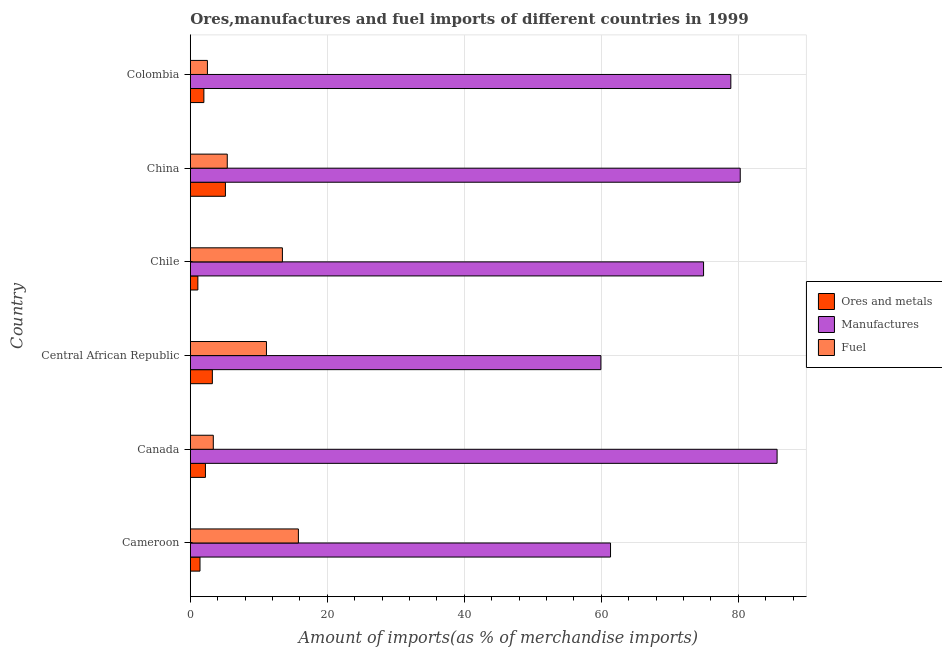How many different coloured bars are there?
Ensure brevity in your answer.  3. Are the number of bars per tick equal to the number of legend labels?
Provide a succinct answer. Yes. What is the label of the 5th group of bars from the top?
Your answer should be very brief. Canada. In how many cases, is the number of bars for a given country not equal to the number of legend labels?
Keep it short and to the point. 0. What is the percentage of manufactures imports in Chile?
Provide a succinct answer. 74.93. Across all countries, what is the maximum percentage of ores and metals imports?
Offer a terse response. 5.13. Across all countries, what is the minimum percentage of ores and metals imports?
Offer a terse response. 1.11. In which country was the percentage of fuel imports maximum?
Provide a succinct answer. Cameroon. What is the total percentage of manufactures imports in the graph?
Keep it short and to the point. 441.09. What is the difference between the percentage of fuel imports in Chile and that in China?
Your response must be concise. 8.05. What is the difference between the percentage of fuel imports in Colombia and the percentage of ores and metals imports in Chile?
Ensure brevity in your answer.  1.4. What is the average percentage of ores and metals imports per country?
Give a very brief answer. 2.51. What is the difference between the percentage of manufactures imports and percentage of fuel imports in Colombia?
Give a very brief answer. 76.41. In how many countries, is the percentage of ores and metals imports greater than 52 %?
Make the answer very short. 0. What is the ratio of the percentage of fuel imports in Canada to that in China?
Offer a terse response. 0.62. What is the difference between the highest and the second highest percentage of ores and metals imports?
Your response must be concise. 1.91. What is the difference between the highest and the lowest percentage of fuel imports?
Your response must be concise. 13.28. What does the 3rd bar from the top in Colombia represents?
Provide a short and direct response. Ores and metals. What does the 2nd bar from the bottom in Colombia represents?
Provide a succinct answer. Manufactures. Are all the bars in the graph horizontal?
Ensure brevity in your answer.  Yes. Does the graph contain any zero values?
Keep it short and to the point. No. Does the graph contain grids?
Offer a very short reply. Yes. How many legend labels are there?
Your answer should be compact. 3. How are the legend labels stacked?
Offer a terse response. Vertical. What is the title of the graph?
Make the answer very short. Ores,manufactures and fuel imports of different countries in 1999. Does "Manufactures" appear as one of the legend labels in the graph?
Your response must be concise. Yes. What is the label or title of the X-axis?
Your response must be concise. Amount of imports(as % of merchandise imports). What is the Amount of imports(as % of merchandise imports) of Ores and metals in Cameroon?
Your answer should be compact. 1.42. What is the Amount of imports(as % of merchandise imports) in Manufactures in Cameroon?
Your response must be concise. 61.35. What is the Amount of imports(as % of merchandise imports) of Fuel in Cameroon?
Your response must be concise. 15.78. What is the Amount of imports(as % of merchandise imports) of Ores and metals in Canada?
Offer a terse response. 2.21. What is the Amount of imports(as % of merchandise imports) of Manufactures in Canada?
Ensure brevity in your answer.  85.67. What is the Amount of imports(as % of merchandise imports) in Fuel in Canada?
Give a very brief answer. 3.36. What is the Amount of imports(as % of merchandise imports) of Ores and metals in Central African Republic?
Offer a very short reply. 3.22. What is the Amount of imports(as % of merchandise imports) of Manufactures in Central African Republic?
Offer a very short reply. 59.94. What is the Amount of imports(as % of merchandise imports) of Fuel in Central African Republic?
Your response must be concise. 11.12. What is the Amount of imports(as % of merchandise imports) in Ores and metals in Chile?
Offer a very short reply. 1.11. What is the Amount of imports(as % of merchandise imports) of Manufactures in Chile?
Offer a terse response. 74.93. What is the Amount of imports(as % of merchandise imports) in Fuel in Chile?
Provide a short and direct response. 13.45. What is the Amount of imports(as % of merchandise imports) of Ores and metals in China?
Provide a succinct answer. 5.13. What is the Amount of imports(as % of merchandise imports) in Manufactures in China?
Offer a terse response. 80.29. What is the Amount of imports(as % of merchandise imports) in Fuel in China?
Ensure brevity in your answer.  5.4. What is the Amount of imports(as % of merchandise imports) of Ores and metals in Colombia?
Your answer should be compact. 1.98. What is the Amount of imports(as % of merchandise imports) of Manufactures in Colombia?
Your response must be concise. 78.91. What is the Amount of imports(as % of merchandise imports) of Fuel in Colombia?
Keep it short and to the point. 2.5. Across all countries, what is the maximum Amount of imports(as % of merchandise imports) of Ores and metals?
Give a very brief answer. 5.13. Across all countries, what is the maximum Amount of imports(as % of merchandise imports) in Manufactures?
Keep it short and to the point. 85.67. Across all countries, what is the maximum Amount of imports(as % of merchandise imports) in Fuel?
Offer a terse response. 15.78. Across all countries, what is the minimum Amount of imports(as % of merchandise imports) of Ores and metals?
Ensure brevity in your answer.  1.11. Across all countries, what is the minimum Amount of imports(as % of merchandise imports) in Manufactures?
Make the answer very short. 59.94. Across all countries, what is the minimum Amount of imports(as % of merchandise imports) of Fuel?
Provide a succinct answer. 2.5. What is the total Amount of imports(as % of merchandise imports) in Ores and metals in the graph?
Your answer should be compact. 15.06. What is the total Amount of imports(as % of merchandise imports) in Manufactures in the graph?
Offer a very short reply. 441.09. What is the total Amount of imports(as % of merchandise imports) of Fuel in the graph?
Offer a very short reply. 51.6. What is the difference between the Amount of imports(as % of merchandise imports) in Ores and metals in Cameroon and that in Canada?
Offer a very short reply. -0.79. What is the difference between the Amount of imports(as % of merchandise imports) of Manufactures in Cameroon and that in Canada?
Provide a succinct answer. -24.32. What is the difference between the Amount of imports(as % of merchandise imports) in Fuel in Cameroon and that in Canada?
Give a very brief answer. 12.42. What is the difference between the Amount of imports(as % of merchandise imports) in Ores and metals in Cameroon and that in Central African Republic?
Provide a short and direct response. -1.8. What is the difference between the Amount of imports(as % of merchandise imports) of Manufactures in Cameroon and that in Central African Republic?
Offer a very short reply. 1.41. What is the difference between the Amount of imports(as % of merchandise imports) in Fuel in Cameroon and that in Central African Republic?
Your answer should be compact. 4.66. What is the difference between the Amount of imports(as % of merchandise imports) in Ores and metals in Cameroon and that in Chile?
Make the answer very short. 0.31. What is the difference between the Amount of imports(as % of merchandise imports) in Manufactures in Cameroon and that in Chile?
Ensure brevity in your answer.  -13.58. What is the difference between the Amount of imports(as % of merchandise imports) of Fuel in Cameroon and that in Chile?
Your answer should be very brief. 2.33. What is the difference between the Amount of imports(as % of merchandise imports) of Ores and metals in Cameroon and that in China?
Ensure brevity in your answer.  -3.71. What is the difference between the Amount of imports(as % of merchandise imports) in Manufactures in Cameroon and that in China?
Provide a short and direct response. -18.94. What is the difference between the Amount of imports(as % of merchandise imports) in Fuel in Cameroon and that in China?
Give a very brief answer. 10.38. What is the difference between the Amount of imports(as % of merchandise imports) in Ores and metals in Cameroon and that in Colombia?
Your response must be concise. -0.57. What is the difference between the Amount of imports(as % of merchandise imports) in Manufactures in Cameroon and that in Colombia?
Your answer should be compact. -17.56. What is the difference between the Amount of imports(as % of merchandise imports) of Fuel in Cameroon and that in Colombia?
Ensure brevity in your answer.  13.28. What is the difference between the Amount of imports(as % of merchandise imports) of Ores and metals in Canada and that in Central African Republic?
Give a very brief answer. -1.01. What is the difference between the Amount of imports(as % of merchandise imports) of Manufactures in Canada and that in Central African Republic?
Ensure brevity in your answer.  25.72. What is the difference between the Amount of imports(as % of merchandise imports) of Fuel in Canada and that in Central African Republic?
Make the answer very short. -7.76. What is the difference between the Amount of imports(as % of merchandise imports) in Ores and metals in Canada and that in Chile?
Make the answer very short. 1.1. What is the difference between the Amount of imports(as % of merchandise imports) in Manufactures in Canada and that in Chile?
Give a very brief answer. 10.74. What is the difference between the Amount of imports(as % of merchandise imports) of Fuel in Canada and that in Chile?
Keep it short and to the point. -10.09. What is the difference between the Amount of imports(as % of merchandise imports) in Ores and metals in Canada and that in China?
Your answer should be compact. -2.92. What is the difference between the Amount of imports(as % of merchandise imports) of Manufactures in Canada and that in China?
Keep it short and to the point. 5.38. What is the difference between the Amount of imports(as % of merchandise imports) of Fuel in Canada and that in China?
Ensure brevity in your answer.  -2.04. What is the difference between the Amount of imports(as % of merchandise imports) in Ores and metals in Canada and that in Colombia?
Keep it short and to the point. 0.23. What is the difference between the Amount of imports(as % of merchandise imports) in Manufactures in Canada and that in Colombia?
Provide a short and direct response. 6.75. What is the difference between the Amount of imports(as % of merchandise imports) of Fuel in Canada and that in Colombia?
Offer a very short reply. 0.86. What is the difference between the Amount of imports(as % of merchandise imports) of Ores and metals in Central African Republic and that in Chile?
Give a very brief answer. 2.12. What is the difference between the Amount of imports(as % of merchandise imports) of Manufactures in Central African Republic and that in Chile?
Give a very brief answer. -14.99. What is the difference between the Amount of imports(as % of merchandise imports) in Fuel in Central African Republic and that in Chile?
Keep it short and to the point. -2.33. What is the difference between the Amount of imports(as % of merchandise imports) in Ores and metals in Central African Republic and that in China?
Give a very brief answer. -1.91. What is the difference between the Amount of imports(as % of merchandise imports) of Manufactures in Central African Republic and that in China?
Offer a very short reply. -20.34. What is the difference between the Amount of imports(as % of merchandise imports) of Fuel in Central African Republic and that in China?
Your answer should be very brief. 5.72. What is the difference between the Amount of imports(as % of merchandise imports) in Ores and metals in Central African Republic and that in Colombia?
Provide a short and direct response. 1.24. What is the difference between the Amount of imports(as % of merchandise imports) in Manufactures in Central African Republic and that in Colombia?
Provide a short and direct response. -18.97. What is the difference between the Amount of imports(as % of merchandise imports) of Fuel in Central African Republic and that in Colombia?
Ensure brevity in your answer.  8.62. What is the difference between the Amount of imports(as % of merchandise imports) in Ores and metals in Chile and that in China?
Your answer should be very brief. -4.02. What is the difference between the Amount of imports(as % of merchandise imports) of Manufactures in Chile and that in China?
Keep it short and to the point. -5.35. What is the difference between the Amount of imports(as % of merchandise imports) of Fuel in Chile and that in China?
Provide a succinct answer. 8.05. What is the difference between the Amount of imports(as % of merchandise imports) in Ores and metals in Chile and that in Colombia?
Offer a terse response. -0.88. What is the difference between the Amount of imports(as % of merchandise imports) in Manufactures in Chile and that in Colombia?
Your answer should be very brief. -3.98. What is the difference between the Amount of imports(as % of merchandise imports) of Fuel in Chile and that in Colombia?
Make the answer very short. 10.95. What is the difference between the Amount of imports(as % of merchandise imports) in Ores and metals in China and that in Colombia?
Offer a very short reply. 3.15. What is the difference between the Amount of imports(as % of merchandise imports) of Manufactures in China and that in Colombia?
Offer a very short reply. 1.37. What is the difference between the Amount of imports(as % of merchandise imports) in Fuel in China and that in Colombia?
Provide a succinct answer. 2.9. What is the difference between the Amount of imports(as % of merchandise imports) of Ores and metals in Cameroon and the Amount of imports(as % of merchandise imports) of Manufactures in Canada?
Your response must be concise. -84.25. What is the difference between the Amount of imports(as % of merchandise imports) in Ores and metals in Cameroon and the Amount of imports(as % of merchandise imports) in Fuel in Canada?
Your answer should be compact. -1.94. What is the difference between the Amount of imports(as % of merchandise imports) of Manufactures in Cameroon and the Amount of imports(as % of merchandise imports) of Fuel in Canada?
Your answer should be very brief. 57.99. What is the difference between the Amount of imports(as % of merchandise imports) of Ores and metals in Cameroon and the Amount of imports(as % of merchandise imports) of Manufactures in Central African Republic?
Provide a short and direct response. -58.53. What is the difference between the Amount of imports(as % of merchandise imports) in Ores and metals in Cameroon and the Amount of imports(as % of merchandise imports) in Fuel in Central African Republic?
Offer a terse response. -9.7. What is the difference between the Amount of imports(as % of merchandise imports) in Manufactures in Cameroon and the Amount of imports(as % of merchandise imports) in Fuel in Central African Republic?
Make the answer very short. 50.23. What is the difference between the Amount of imports(as % of merchandise imports) of Ores and metals in Cameroon and the Amount of imports(as % of merchandise imports) of Manufactures in Chile?
Keep it short and to the point. -73.51. What is the difference between the Amount of imports(as % of merchandise imports) in Ores and metals in Cameroon and the Amount of imports(as % of merchandise imports) in Fuel in Chile?
Make the answer very short. -12.03. What is the difference between the Amount of imports(as % of merchandise imports) in Manufactures in Cameroon and the Amount of imports(as % of merchandise imports) in Fuel in Chile?
Provide a short and direct response. 47.9. What is the difference between the Amount of imports(as % of merchandise imports) of Ores and metals in Cameroon and the Amount of imports(as % of merchandise imports) of Manufactures in China?
Provide a short and direct response. -78.87. What is the difference between the Amount of imports(as % of merchandise imports) of Ores and metals in Cameroon and the Amount of imports(as % of merchandise imports) of Fuel in China?
Provide a succinct answer. -3.98. What is the difference between the Amount of imports(as % of merchandise imports) in Manufactures in Cameroon and the Amount of imports(as % of merchandise imports) in Fuel in China?
Ensure brevity in your answer.  55.95. What is the difference between the Amount of imports(as % of merchandise imports) in Ores and metals in Cameroon and the Amount of imports(as % of merchandise imports) in Manufactures in Colombia?
Your answer should be compact. -77.5. What is the difference between the Amount of imports(as % of merchandise imports) of Ores and metals in Cameroon and the Amount of imports(as % of merchandise imports) of Fuel in Colombia?
Provide a succinct answer. -1.08. What is the difference between the Amount of imports(as % of merchandise imports) of Manufactures in Cameroon and the Amount of imports(as % of merchandise imports) of Fuel in Colombia?
Your answer should be very brief. 58.85. What is the difference between the Amount of imports(as % of merchandise imports) of Ores and metals in Canada and the Amount of imports(as % of merchandise imports) of Manufactures in Central African Republic?
Ensure brevity in your answer.  -57.73. What is the difference between the Amount of imports(as % of merchandise imports) of Ores and metals in Canada and the Amount of imports(as % of merchandise imports) of Fuel in Central African Republic?
Your response must be concise. -8.91. What is the difference between the Amount of imports(as % of merchandise imports) in Manufactures in Canada and the Amount of imports(as % of merchandise imports) in Fuel in Central African Republic?
Give a very brief answer. 74.55. What is the difference between the Amount of imports(as % of merchandise imports) of Ores and metals in Canada and the Amount of imports(as % of merchandise imports) of Manufactures in Chile?
Give a very brief answer. -72.72. What is the difference between the Amount of imports(as % of merchandise imports) of Ores and metals in Canada and the Amount of imports(as % of merchandise imports) of Fuel in Chile?
Your answer should be compact. -11.24. What is the difference between the Amount of imports(as % of merchandise imports) in Manufactures in Canada and the Amount of imports(as % of merchandise imports) in Fuel in Chile?
Give a very brief answer. 72.22. What is the difference between the Amount of imports(as % of merchandise imports) in Ores and metals in Canada and the Amount of imports(as % of merchandise imports) in Manufactures in China?
Your answer should be compact. -78.08. What is the difference between the Amount of imports(as % of merchandise imports) in Ores and metals in Canada and the Amount of imports(as % of merchandise imports) in Fuel in China?
Provide a succinct answer. -3.19. What is the difference between the Amount of imports(as % of merchandise imports) in Manufactures in Canada and the Amount of imports(as % of merchandise imports) in Fuel in China?
Your answer should be compact. 80.27. What is the difference between the Amount of imports(as % of merchandise imports) of Ores and metals in Canada and the Amount of imports(as % of merchandise imports) of Manufactures in Colombia?
Provide a short and direct response. -76.7. What is the difference between the Amount of imports(as % of merchandise imports) in Ores and metals in Canada and the Amount of imports(as % of merchandise imports) in Fuel in Colombia?
Provide a succinct answer. -0.29. What is the difference between the Amount of imports(as % of merchandise imports) of Manufactures in Canada and the Amount of imports(as % of merchandise imports) of Fuel in Colombia?
Offer a terse response. 83.16. What is the difference between the Amount of imports(as % of merchandise imports) of Ores and metals in Central African Republic and the Amount of imports(as % of merchandise imports) of Manufactures in Chile?
Keep it short and to the point. -71.71. What is the difference between the Amount of imports(as % of merchandise imports) in Ores and metals in Central African Republic and the Amount of imports(as % of merchandise imports) in Fuel in Chile?
Offer a very short reply. -10.23. What is the difference between the Amount of imports(as % of merchandise imports) of Manufactures in Central African Republic and the Amount of imports(as % of merchandise imports) of Fuel in Chile?
Your answer should be very brief. 46.49. What is the difference between the Amount of imports(as % of merchandise imports) in Ores and metals in Central African Republic and the Amount of imports(as % of merchandise imports) in Manufactures in China?
Offer a very short reply. -77.06. What is the difference between the Amount of imports(as % of merchandise imports) of Ores and metals in Central African Republic and the Amount of imports(as % of merchandise imports) of Fuel in China?
Your response must be concise. -2.18. What is the difference between the Amount of imports(as % of merchandise imports) of Manufactures in Central African Republic and the Amount of imports(as % of merchandise imports) of Fuel in China?
Your answer should be very brief. 54.54. What is the difference between the Amount of imports(as % of merchandise imports) in Ores and metals in Central African Republic and the Amount of imports(as % of merchandise imports) in Manufactures in Colombia?
Your response must be concise. -75.69. What is the difference between the Amount of imports(as % of merchandise imports) of Ores and metals in Central African Republic and the Amount of imports(as % of merchandise imports) of Fuel in Colombia?
Provide a short and direct response. 0.72. What is the difference between the Amount of imports(as % of merchandise imports) in Manufactures in Central African Republic and the Amount of imports(as % of merchandise imports) in Fuel in Colombia?
Provide a succinct answer. 57.44. What is the difference between the Amount of imports(as % of merchandise imports) of Ores and metals in Chile and the Amount of imports(as % of merchandise imports) of Manufactures in China?
Give a very brief answer. -79.18. What is the difference between the Amount of imports(as % of merchandise imports) of Ores and metals in Chile and the Amount of imports(as % of merchandise imports) of Fuel in China?
Provide a succinct answer. -4.29. What is the difference between the Amount of imports(as % of merchandise imports) of Manufactures in Chile and the Amount of imports(as % of merchandise imports) of Fuel in China?
Offer a very short reply. 69.53. What is the difference between the Amount of imports(as % of merchandise imports) of Ores and metals in Chile and the Amount of imports(as % of merchandise imports) of Manufactures in Colombia?
Give a very brief answer. -77.81. What is the difference between the Amount of imports(as % of merchandise imports) of Ores and metals in Chile and the Amount of imports(as % of merchandise imports) of Fuel in Colombia?
Provide a succinct answer. -1.4. What is the difference between the Amount of imports(as % of merchandise imports) of Manufactures in Chile and the Amount of imports(as % of merchandise imports) of Fuel in Colombia?
Provide a succinct answer. 72.43. What is the difference between the Amount of imports(as % of merchandise imports) in Ores and metals in China and the Amount of imports(as % of merchandise imports) in Manufactures in Colombia?
Make the answer very short. -73.78. What is the difference between the Amount of imports(as % of merchandise imports) in Ores and metals in China and the Amount of imports(as % of merchandise imports) in Fuel in Colombia?
Make the answer very short. 2.63. What is the difference between the Amount of imports(as % of merchandise imports) of Manufactures in China and the Amount of imports(as % of merchandise imports) of Fuel in Colombia?
Offer a very short reply. 77.78. What is the average Amount of imports(as % of merchandise imports) of Ores and metals per country?
Provide a short and direct response. 2.51. What is the average Amount of imports(as % of merchandise imports) of Manufactures per country?
Provide a succinct answer. 73.51. What is the average Amount of imports(as % of merchandise imports) of Fuel per country?
Offer a very short reply. 8.6. What is the difference between the Amount of imports(as % of merchandise imports) of Ores and metals and Amount of imports(as % of merchandise imports) of Manufactures in Cameroon?
Provide a succinct answer. -59.93. What is the difference between the Amount of imports(as % of merchandise imports) in Ores and metals and Amount of imports(as % of merchandise imports) in Fuel in Cameroon?
Your answer should be very brief. -14.36. What is the difference between the Amount of imports(as % of merchandise imports) in Manufactures and Amount of imports(as % of merchandise imports) in Fuel in Cameroon?
Your answer should be compact. 45.57. What is the difference between the Amount of imports(as % of merchandise imports) in Ores and metals and Amount of imports(as % of merchandise imports) in Manufactures in Canada?
Offer a very short reply. -83.46. What is the difference between the Amount of imports(as % of merchandise imports) in Ores and metals and Amount of imports(as % of merchandise imports) in Fuel in Canada?
Ensure brevity in your answer.  -1.15. What is the difference between the Amount of imports(as % of merchandise imports) of Manufactures and Amount of imports(as % of merchandise imports) of Fuel in Canada?
Offer a terse response. 82.31. What is the difference between the Amount of imports(as % of merchandise imports) in Ores and metals and Amount of imports(as % of merchandise imports) in Manufactures in Central African Republic?
Provide a short and direct response. -56.72. What is the difference between the Amount of imports(as % of merchandise imports) in Ores and metals and Amount of imports(as % of merchandise imports) in Fuel in Central African Republic?
Give a very brief answer. -7.9. What is the difference between the Amount of imports(as % of merchandise imports) in Manufactures and Amount of imports(as % of merchandise imports) in Fuel in Central African Republic?
Give a very brief answer. 48.82. What is the difference between the Amount of imports(as % of merchandise imports) in Ores and metals and Amount of imports(as % of merchandise imports) in Manufactures in Chile?
Your answer should be compact. -73.83. What is the difference between the Amount of imports(as % of merchandise imports) in Ores and metals and Amount of imports(as % of merchandise imports) in Fuel in Chile?
Offer a terse response. -12.34. What is the difference between the Amount of imports(as % of merchandise imports) of Manufactures and Amount of imports(as % of merchandise imports) of Fuel in Chile?
Make the answer very short. 61.48. What is the difference between the Amount of imports(as % of merchandise imports) in Ores and metals and Amount of imports(as % of merchandise imports) in Manufactures in China?
Provide a short and direct response. -75.16. What is the difference between the Amount of imports(as % of merchandise imports) of Ores and metals and Amount of imports(as % of merchandise imports) of Fuel in China?
Offer a terse response. -0.27. What is the difference between the Amount of imports(as % of merchandise imports) of Manufactures and Amount of imports(as % of merchandise imports) of Fuel in China?
Your answer should be very brief. 74.89. What is the difference between the Amount of imports(as % of merchandise imports) of Ores and metals and Amount of imports(as % of merchandise imports) of Manufactures in Colombia?
Provide a succinct answer. -76.93. What is the difference between the Amount of imports(as % of merchandise imports) in Ores and metals and Amount of imports(as % of merchandise imports) in Fuel in Colombia?
Ensure brevity in your answer.  -0.52. What is the difference between the Amount of imports(as % of merchandise imports) in Manufactures and Amount of imports(as % of merchandise imports) in Fuel in Colombia?
Your answer should be compact. 76.41. What is the ratio of the Amount of imports(as % of merchandise imports) of Ores and metals in Cameroon to that in Canada?
Your response must be concise. 0.64. What is the ratio of the Amount of imports(as % of merchandise imports) in Manufactures in Cameroon to that in Canada?
Provide a succinct answer. 0.72. What is the ratio of the Amount of imports(as % of merchandise imports) of Fuel in Cameroon to that in Canada?
Your answer should be very brief. 4.7. What is the ratio of the Amount of imports(as % of merchandise imports) of Ores and metals in Cameroon to that in Central African Republic?
Ensure brevity in your answer.  0.44. What is the ratio of the Amount of imports(as % of merchandise imports) of Manufactures in Cameroon to that in Central African Republic?
Your answer should be very brief. 1.02. What is the ratio of the Amount of imports(as % of merchandise imports) in Fuel in Cameroon to that in Central African Republic?
Offer a very short reply. 1.42. What is the ratio of the Amount of imports(as % of merchandise imports) in Ores and metals in Cameroon to that in Chile?
Your answer should be very brief. 1.28. What is the ratio of the Amount of imports(as % of merchandise imports) in Manufactures in Cameroon to that in Chile?
Offer a very short reply. 0.82. What is the ratio of the Amount of imports(as % of merchandise imports) of Fuel in Cameroon to that in Chile?
Keep it short and to the point. 1.17. What is the ratio of the Amount of imports(as % of merchandise imports) in Ores and metals in Cameroon to that in China?
Provide a short and direct response. 0.28. What is the ratio of the Amount of imports(as % of merchandise imports) of Manufactures in Cameroon to that in China?
Ensure brevity in your answer.  0.76. What is the ratio of the Amount of imports(as % of merchandise imports) in Fuel in Cameroon to that in China?
Make the answer very short. 2.92. What is the ratio of the Amount of imports(as % of merchandise imports) in Ores and metals in Cameroon to that in Colombia?
Your answer should be very brief. 0.71. What is the ratio of the Amount of imports(as % of merchandise imports) of Manufactures in Cameroon to that in Colombia?
Your answer should be compact. 0.78. What is the ratio of the Amount of imports(as % of merchandise imports) of Fuel in Cameroon to that in Colombia?
Keep it short and to the point. 6.31. What is the ratio of the Amount of imports(as % of merchandise imports) of Ores and metals in Canada to that in Central African Republic?
Offer a very short reply. 0.69. What is the ratio of the Amount of imports(as % of merchandise imports) of Manufactures in Canada to that in Central African Republic?
Ensure brevity in your answer.  1.43. What is the ratio of the Amount of imports(as % of merchandise imports) in Fuel in Canada to that in Central African Republic?
Ensure brevity in your answer.  0.3. What is the ratio of the Amount of imports(as % of merchandise imports) in Ores and metals in Canada to that in Chile?
Offer a very short reply. 2. What is the ratio of the Amount of imports(as % of merchandise imports) of Manufactures in Canada to that in Chile?
Ensure brevity in your answer.  1.14. What is the ratio of the Amount of imports(as % of merchandise imports) of Fuel in Canada to that in Chile?
Provide a succinct answer. 0.25. What is the ratio of the Amount of imports(as % of merchandise imports) in Ores and metals in Canada to that in China?
Your response must be concise. 0.43. What is the ratio of the Amount of imports(as % of merchandise imports) in Manufactures in Canada to that in China?
Give a very brief answer. 1.07. What is the ratio of the Amount of imports(as % of merchandise imports) of Fuel in Canada to that in China?
Offer a terse response. 0.62. What is the ratio of the Amount of imports(as % of merchandise imports) in Ores and metals in Canada to that in Colombia?
Give a very brief answer. 1.11. What is the ratio of the Amount of imports(as % of merchandise imports) in Manufactures in Canada to that in Colombia?
Keep it short and to the point. 1.09. What is the ratio of the Amount of imports(as % of merchandise imports) of Fuel in Canada to that in Colombia?
Your response must be concise. 1.34. What is the ratio of the Amount of imports(as % of merchandise imports) in Ores and metals in Central African Republic to that in Chile?
Offer a terse response. 2.91. What is the ratio of the Amount of imports(as % of merchandise imports) of Manufactures in Central African Republic to that in Chile?
Offer a very short reply. 0.8. What is the ratio of the Amount of imports(as % of merchandise imports) of Fuel in Central African Republic to that in Chile?
Your answer should be compact. 0.83. What is the ratio of the Amount of imports(as % of merchandise imports) of Ores and metals in Central African Republic to that in China?
Provide a short and direct response. 0.63. What is the ratio of the Amount of imports(as % of merchandise imports) in Manufactures in Central African Republic to that in China?
Your response must be concise. 0.75. What is the ratio of the Amount of imports(as % of merchandise imports) of Fuel in Central African Republic to that in China?
Provide a short and direct response. 2.06. What is the ratio of the Amount of imports(as % of merchandise imports) of Ores and metals in Central African Republic to that in Colombia?
Make the answer very short. 1.63. What is the ratio of the Amount of imports(as % of merchandise imports) of Manufactures in Central African Republic to that in Colombia?
Provide a short and direct response. 0.76. What is the ratio of the Amount of imports(as % of merchandise imports) of Fuel in Central African Republic to that in Colombia?
Your answer should be very brief. 4.44. What is the ratio of the Amount of imports(as % of merchandise imports) in Ores and metals in Chile to that in China?
Your answer should be very brief. 0.22. What is the ratio of the Amount of imports(as % of merchandise imports) of Manufactures in Chile to that in China?
Ensure brevity in your answer.  0.93. What is the ratio of the Amount of imports(as % of merchandise imports) in Fuel in Chile to that in China?
Your response must be concise. 2.49. What is the ratio of the Amount of imports(as % of merchandise imports) in Ores and metals in Chile to that in Colombia?
Ensure brevity in your answer.  0.56. What is the ratio of the Amount of imports(as % of merchandise imports) of Manufactures in Chile to that in Colombia?
Make the answer very short. 0.95. What is the ratio of the Amount of imports(as % of merchandise imports) in Fuel in Chile to that in Colombia?
Offer a terse response. 5.38. What is the ratio of the Amount of imports(as % of merchandise imports) in Ores and metals in China to that in Colombia?
Make the answer very short. 2.59. What is the ratio of the Amount of imports(as % of merchandise imports) of Manufactures in China to that in Colombia?
Your response must be concise. 1.02. What is the ratio of the Amount of imports(as % of merchandise imports) in Fuel in China to that in Colombia?
Keep it short and to the point. 2.16. What is the difference between the highest and the second highest Amount of imports(as % of merchandise imports) of Ores and metals?
Give a very brief answer. 1.91. What is the difference between the highest and the second highest Amount of imports(as % of merchandise imports) of Manufactures?
Your answer should be very brief. 5.38. What is the difference between the highest and the second highest Amount of imports(as % of merchandise imports) of Fuel?
Provide a succinct answer. 2.33. What is the difference between the highest and the lowest Amount of imports(as % of merchandise imports) of Ores and metals?
Make the answer very short. 4.02. What is the difference between the highest and the lowest Amount of imports(as % of merchandise imports) of Manufactures?
Offer a terse response. 25.72. What is the difference between the highest and the lowest Amount of imports(as % of merchandise imports) in Fuel?
Your answer should be compact. 13.28. 